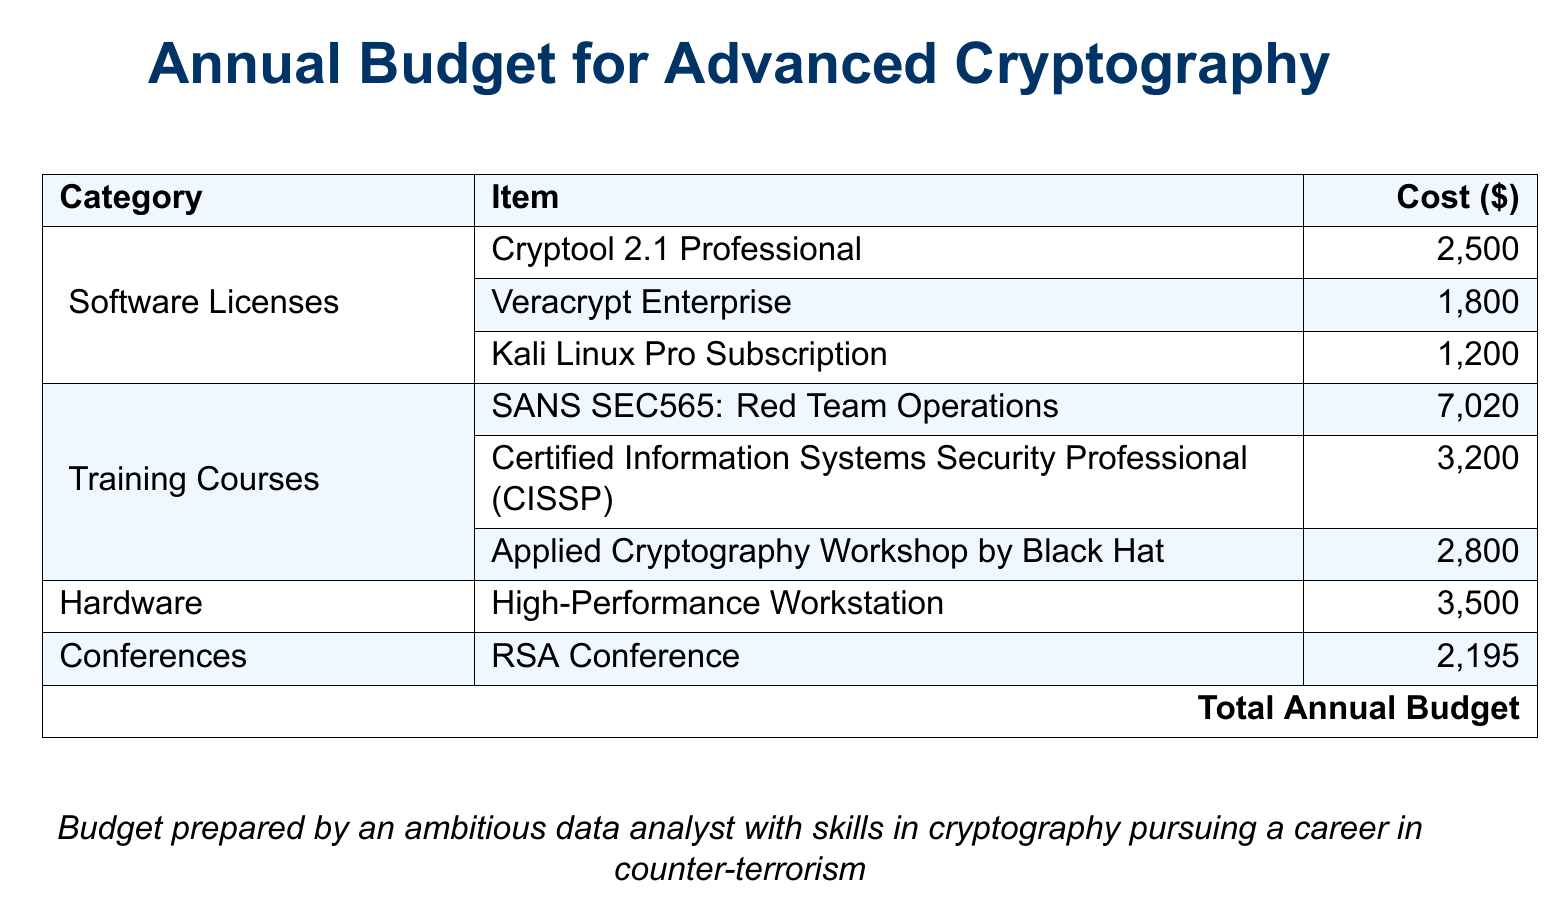What is the total cost of software licenses? The total cost of software licenses is the sum of the individual license costs for Cryptool 2.1 Professional, Veracrypt Enterprise, and Kali Linux Pro Subscription, which is $2500 + $1800 + $1200 = $5500.
Answer: $5500 What training course costs the most? The training course that costs the most is SANS SEC565: Red Team Operations, which is listed at $7020.
Answer: SANS SEC565: Red Team Operations How many training courses are listed in the budget? The budget lists a total of three training courses: SANS SEC565, CISSP, and Applied Cryptography Workshop.
Answer: 3 What is the cost of the High-Performance Workstation? The cost of the High-Performance Workstation is stated as $3500.
Answer: $3500 What is the total annual budget? The total annual budget is the grand total of all items listed, calculated to be $24215.
Answer: $24215 Which conference is included in the budget? The conference included in the budget is the RSA Conference, which costs $2195.
Answer: RSA Conference Which item in the budget has a cost of $1800? The item in the budget that has a cost of $1800 is Veracrypt Enterprise.
Answer: Veracrypt Enterprise What category does the High-Performance Workstation fall under? The High-Performance Workstation is listed under the Hardware category in the budget.
Answer: Hardware How many items are listed under Software Licenses? There are three items listed under Software Licenses: Cryptool, Veracrypt, and Kali Linux.
Answer: 3 